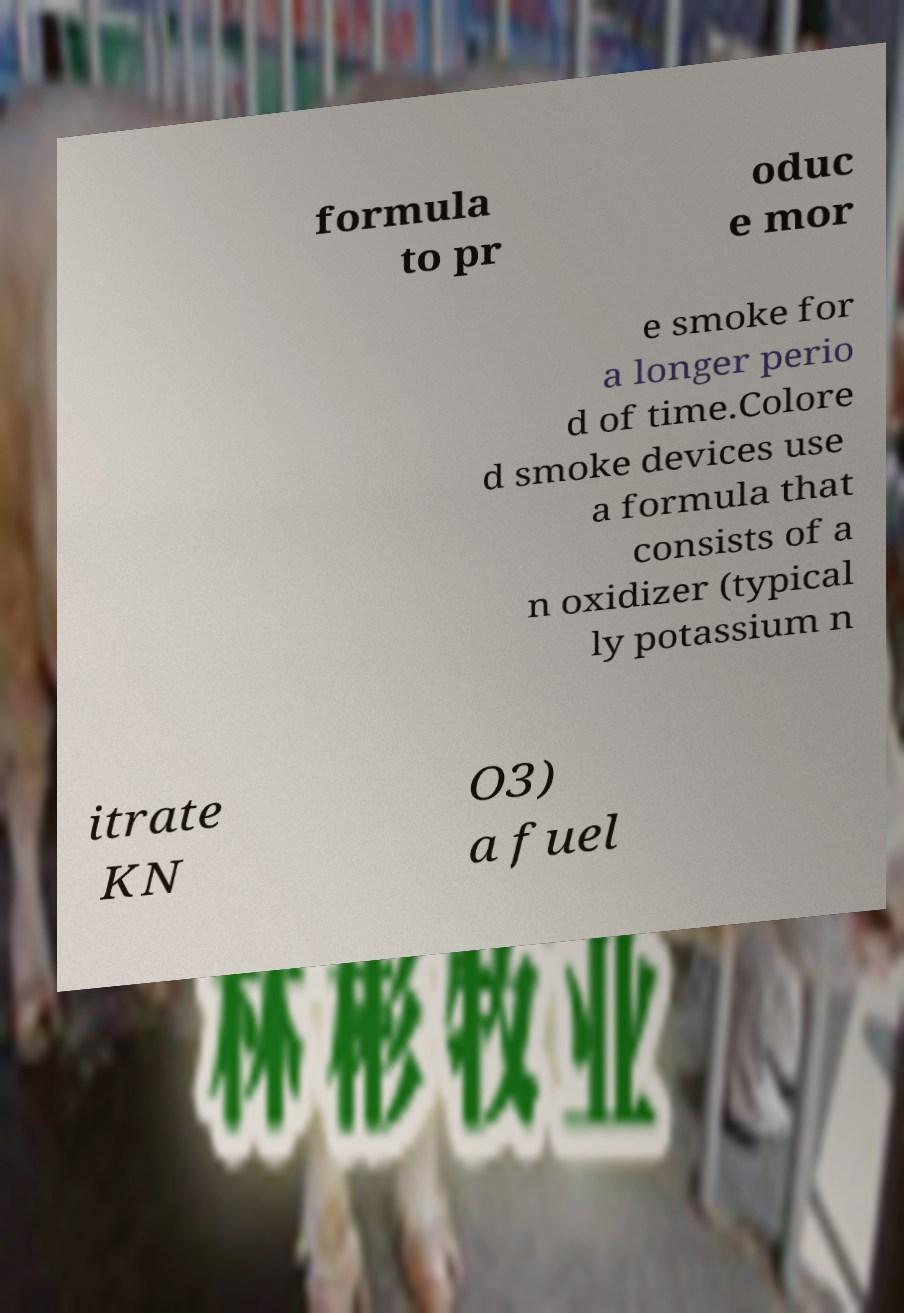Can you accurately transcribe the text from the provided image for me? formula to pr oduc e mor e smoke for a longer perio d of time.Colore d smoke devices use a formula that consists of a n oxidizer (typical ly potassium n itrate KN O3) a fuel 